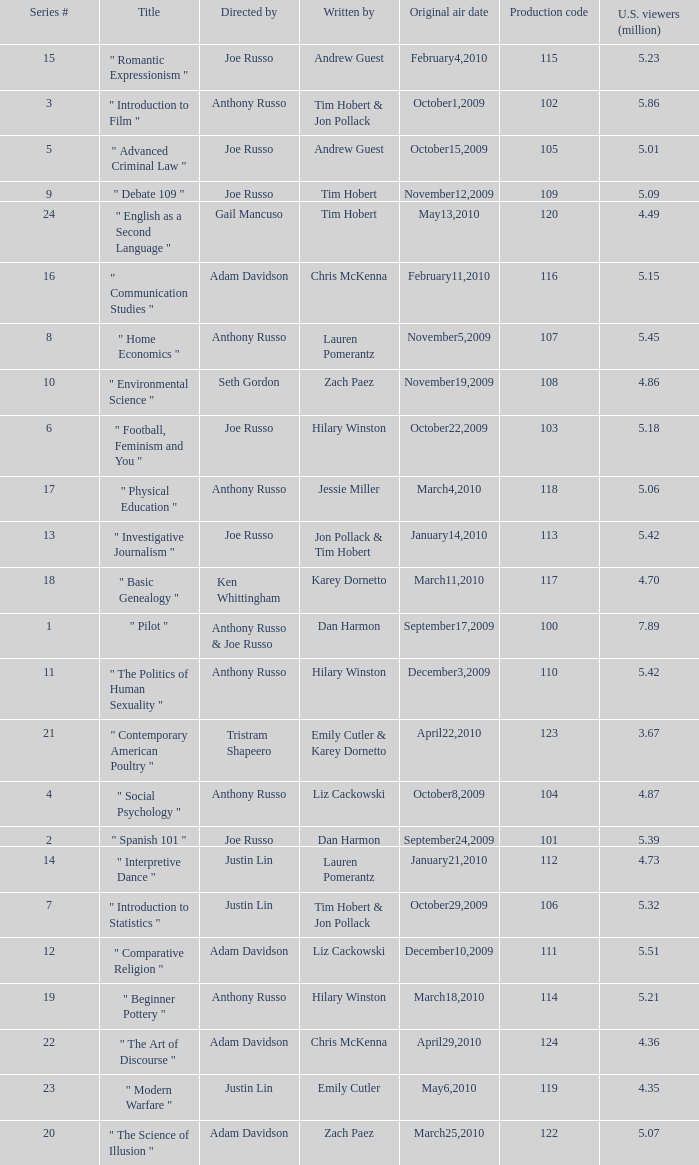What is the highest series # directed by ken whittingham? 18.0. 